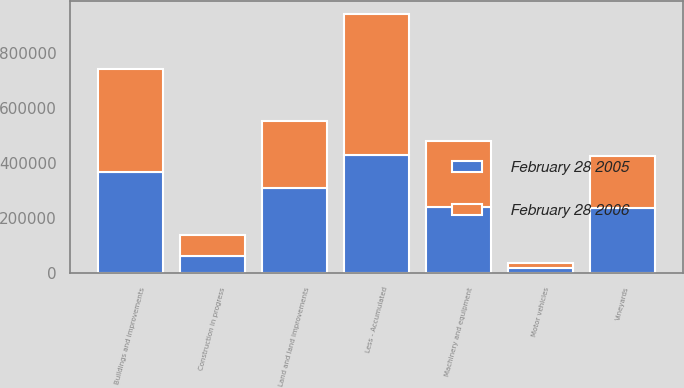Convert chart to OTSL. <chart><loc_0><loc_0><loc_500><loc_500><stacked_bar_chart><ecel><fcel>Land and land improvements<fcel>Vineyards<fcel>Buildings and improvements<fcel>Machinery and equipment<fcel>Motor vehicles<fcel>Construction in progress<fcel>Less - Accumulated<nl><fcel>February 28 2006<fcel>245237<fcel>187651<fcel>373160<fcel>241032<fcel>16226<fcel>73876<fcel>513059<nl><fcel>February 28 2005<fcel>308119<fcel>236827<fcel>367544<fcel>241032<fcel>19351<fcel>63776<fcel>428547<nl></chart> 